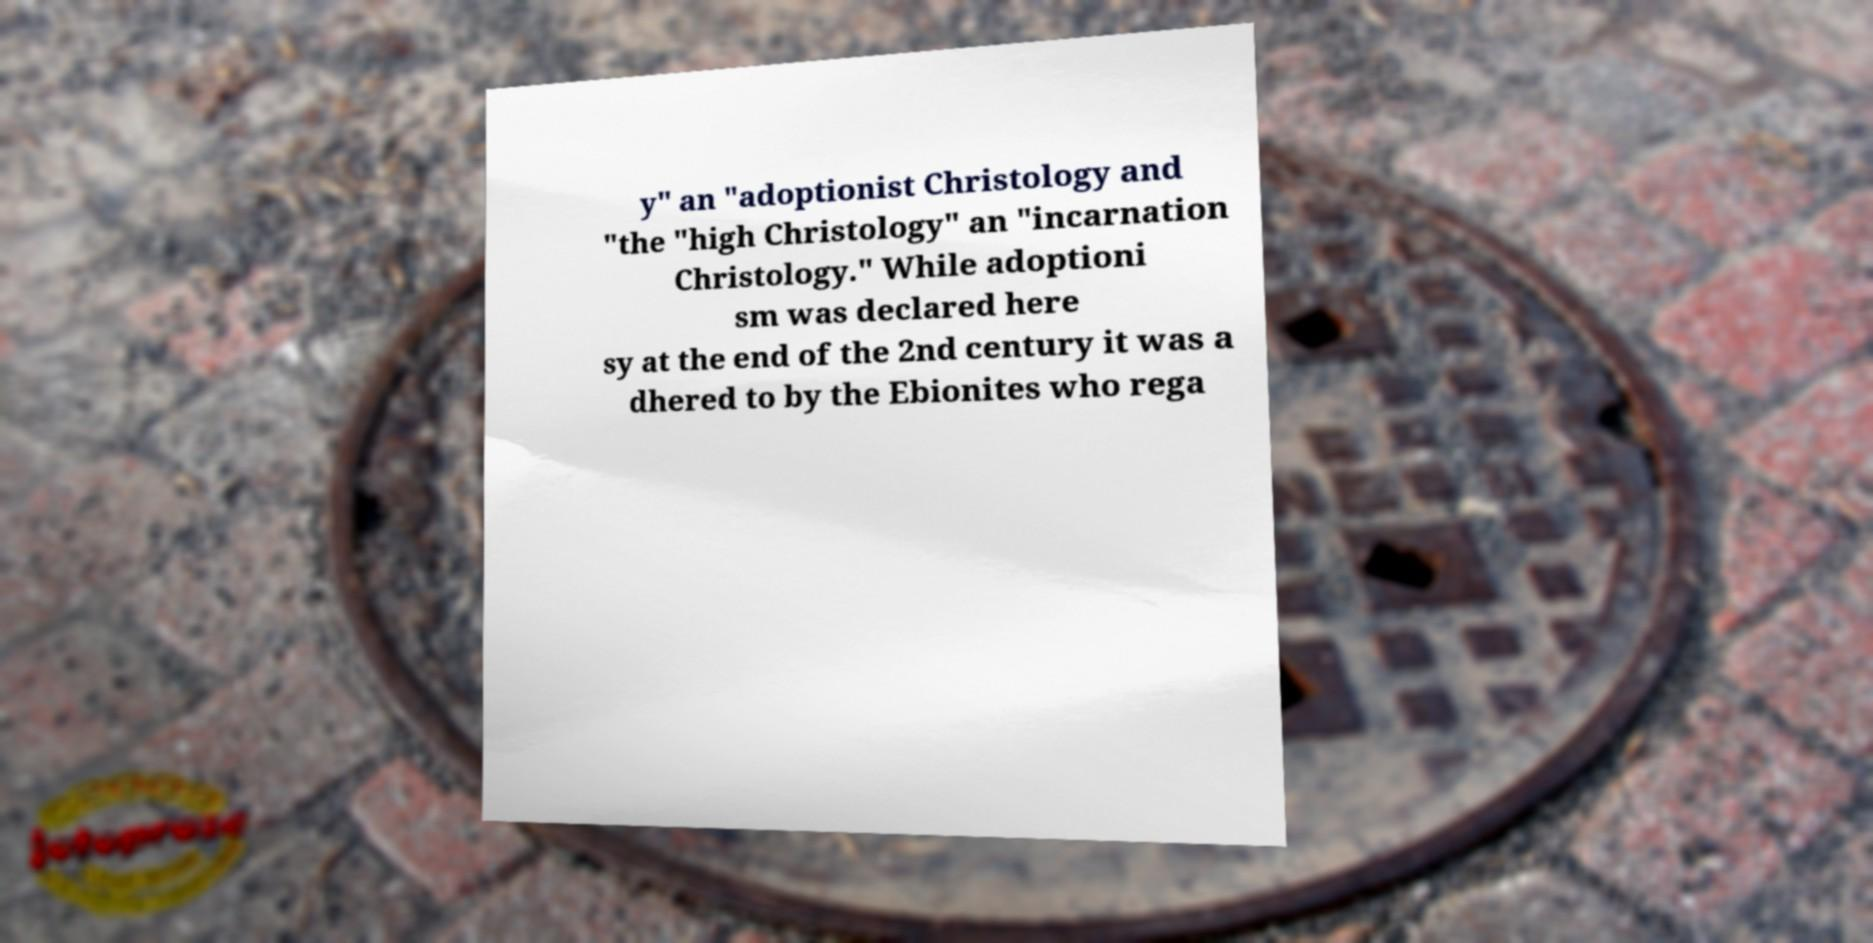Could you extract and type out the text from this image? y" an "adoptionist Christology and "the "high Christology" an "incarnation Christology." While adoptioni sm was declared here sy at the end of the 2nd century it was a dhered to by the Ebionites who rega 